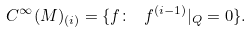Convert formula to latex. <formula><loc_0><loc_0><loc_500><loc_500>C ^ { \infty } ( M ) _ { ( i ) } = \{ f \colon \ f ^ { ( i - 1 ) } | _ { Q } = 0 \} .</formula> 